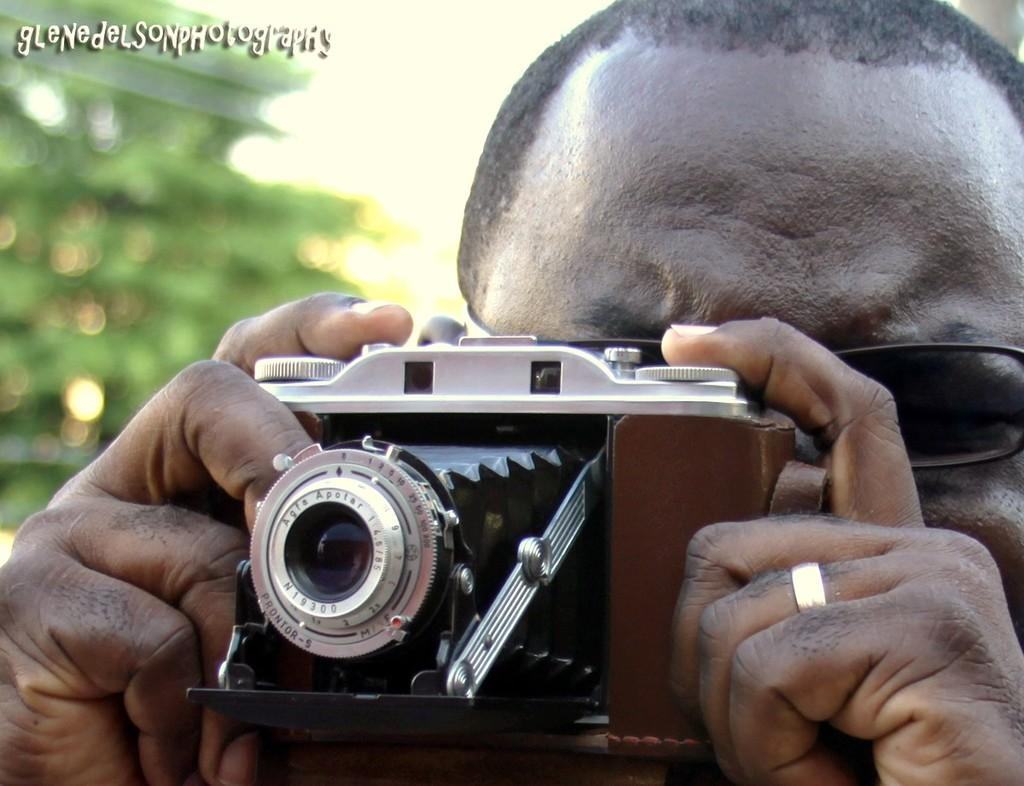What is the main subject of the image? The main subject of the image is a man. What is the man holding in his hand? The man is carrying a camera in his hand. Is the man wearing a mask in the image? There is no mention of a mask in the image, so we cannot determine if the man is wearing one. 